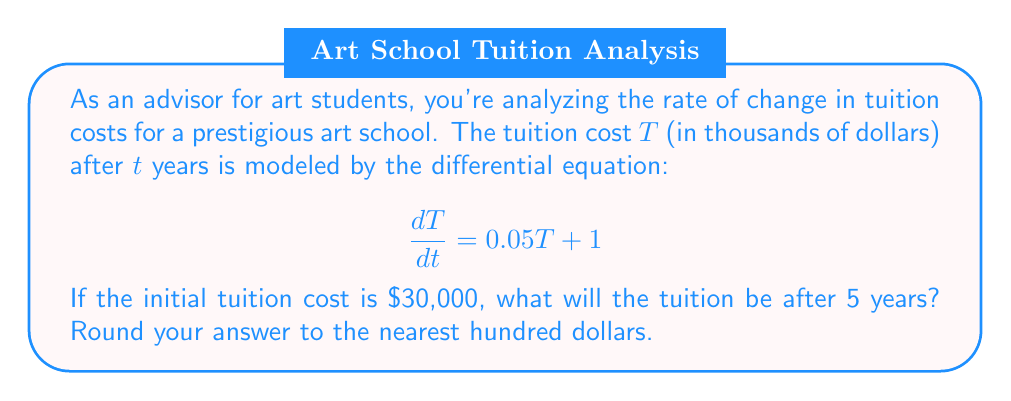Could you help me with this problem? Let's solve this step-by-step:

1) We have a first-order linear differential equation:
   $$\frac{dT}{dt} = 0.05T + 1$$

2) This is in the form $\frac{dT}{dt} + P(t)T = Q(t)$, where $P(t) = -0.05$ and $Q(t) = 1$.

3) The integrating factor is $e^{\int P(t)dt} = e^{-0.05t}$.

4) Multiplying both sides by the integrating factor:
   $$e^{-0.05t}\frac{dT}{dt} + 0.05e^{-0.05t}T = e^{-0.05t}$$

5) This simplifies to:
   $$\frac{d}{dt}(e^{-0.05t}T) = e^{-0.05t}$$

6) Integrating both sides:
   $$e^{-0.05t}T = -20e^{-0.05t} + C$$

7) Solving for $T$:
   $$T = -20 + Ce^{0.05t}$$

8) Using the initial condition $T(0) = 30$:
   $$30 = -20 + C$$
   $$C = 50$$

9) Therefore, the general solution is:
   $$T = -20 + 50e^{0.05t}$$

10) To find the tuition after 5 years, we calculate $T(5)$:
    $$T(5) = -20 + 50e^{0.05(5)} = -20 + 50e^{0.25} \approx 44.10957$$

11) Converting to dollars and rounding to the nearest hundred:
    $44.10957 * 1000 \approx 44,100$
Answer: $44,100 